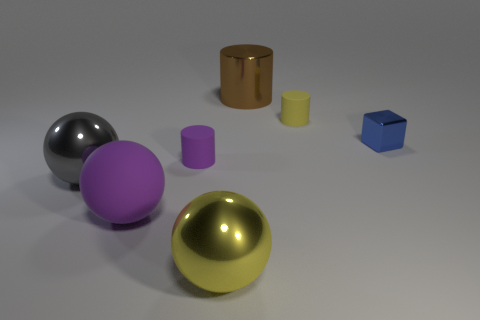What is the shape of the rubber thing that is the same color as the big rubber sphere?
Ensure brevity in your answer.  Cylinder. What is the color of the metal cylinder that is the same size as the yellow sphere?
Provide a short and direct response. Brown. There is a tiny yellow matte object; is it the same shape as the thing that is left of the big purple thing?
Ensure brevity in your answer.  No. The cylinder to the right of the brown cylinder that is right of the tiny rubber thing in front of the yellow rubber cylinder is made of what material?
Your answer should be compact. Rubber. How many small objects are yellow shiny spheres or red cubes?
Offer a terse response. 0. What number of other objects are there of the same size as the yellow shiny thing?
Provide a short and direct response. 3. Do the yellow rubber thing behind the big gray shiny ball and the brown object have the same shape?
Keep it short and to the point. Yes. What is the color of the other metal object that is the same shape as the big gray thing?
Provide a short and direct response. Yellow. Is there anything else that has the same shape as the large yellow metallic thing?
Make the answer very short. Yes. Are there an equal number of yellow cylinders behind the small yellow rubber object and blue metal objects?
Your answer should be very brief. No. 